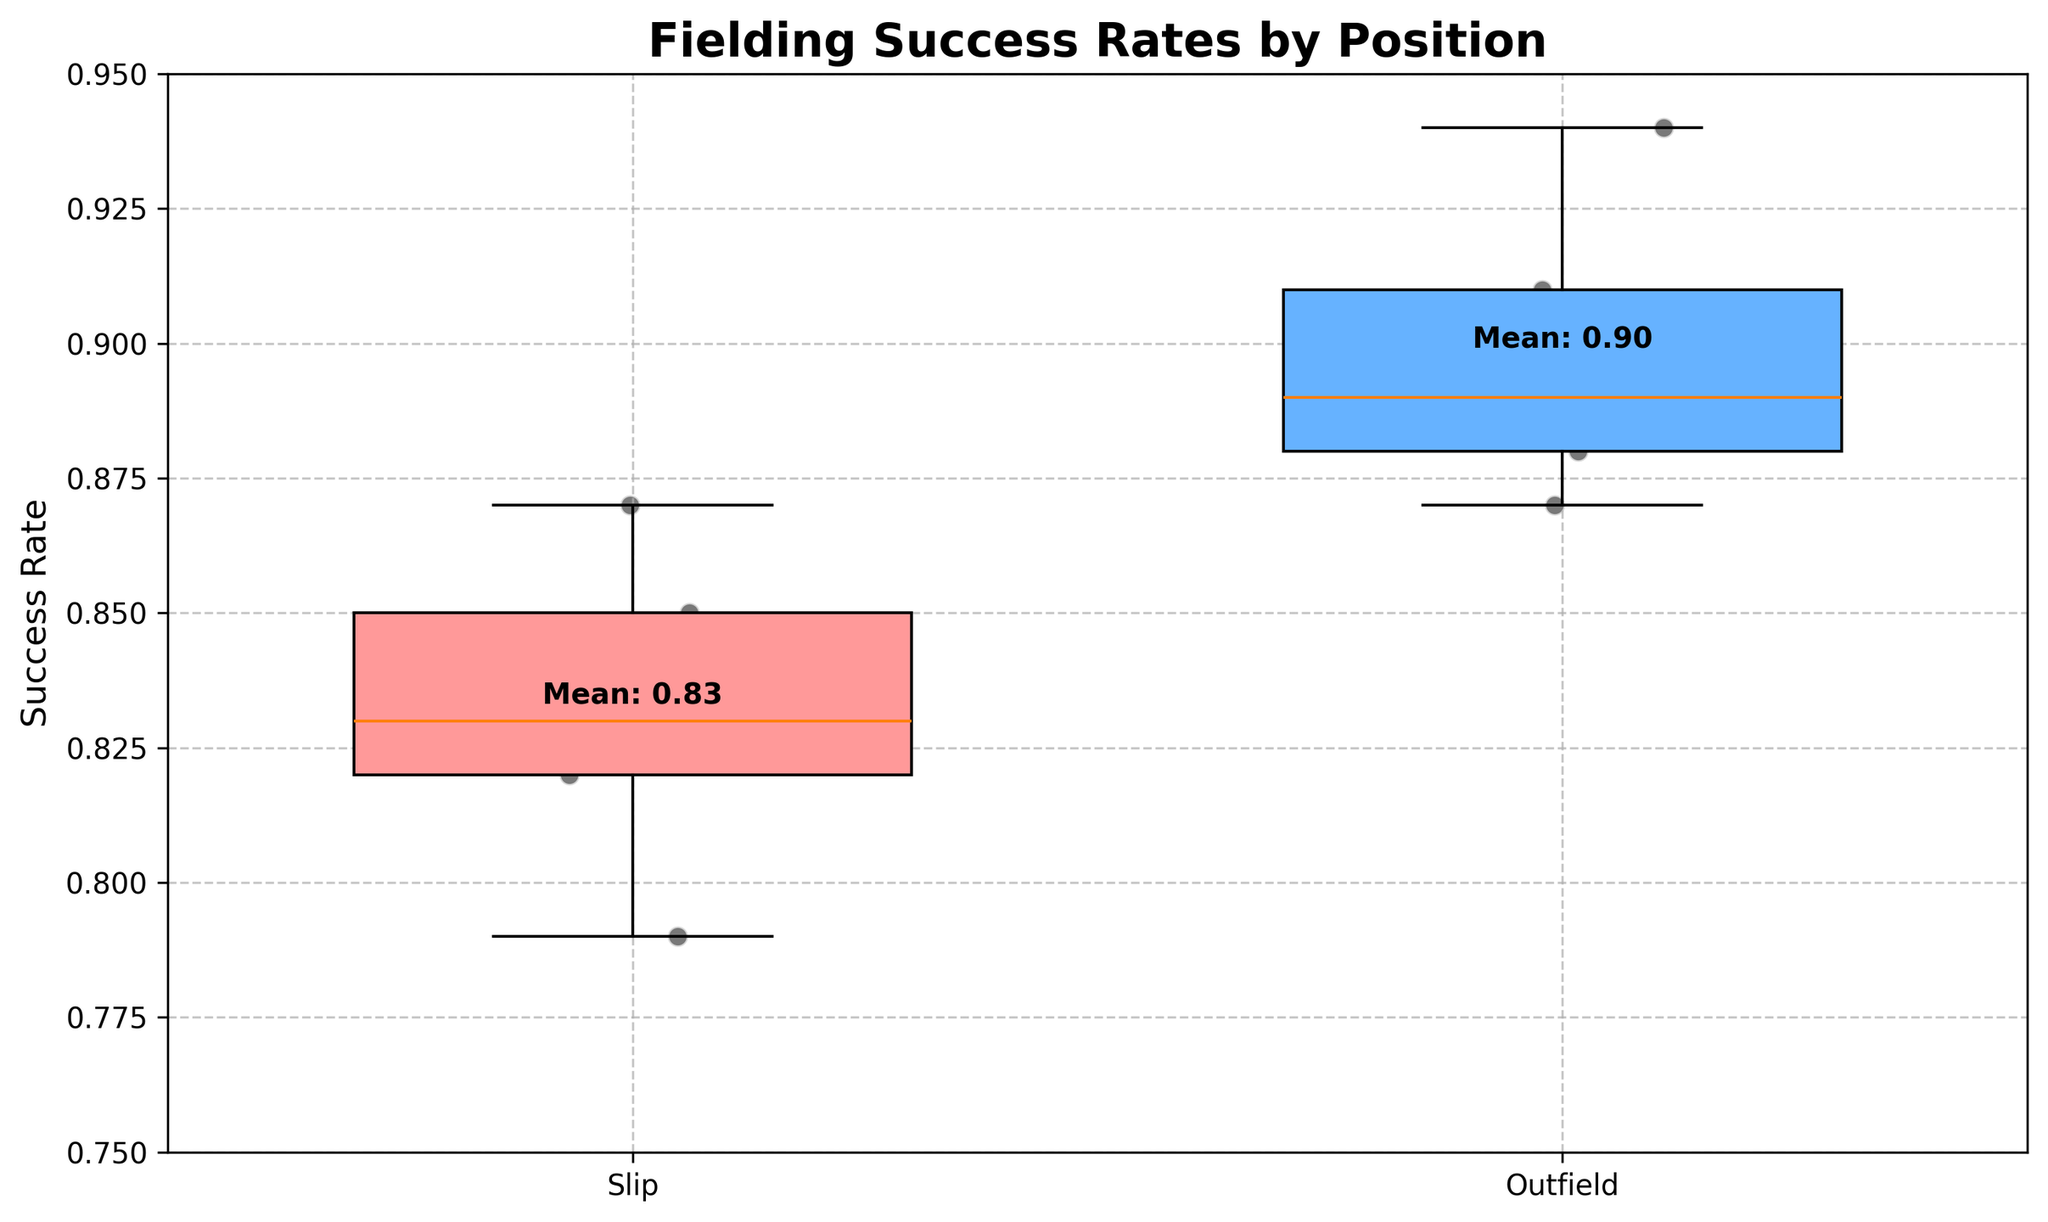How many data points represent the success rate for slip fielders? Count the number of data points in the "slip" category on the box plot
Answer: 5 What is the title of the plot? Read the text at the top of the plot
Answer: Fielding Success Rates by Position Which fielding position has the higher mean success rate? Look at the mean value labels on the plot. Compare the means for slip and outfield
Answer: Outfield What is the range of success rates for outfield players? Identify the minimum and maximum values from the box plot for the outfield group
Answer: 0.87 to 0.94 How does the interquartile range (IQR) for slip fielders compare to the IQR for outfielders? Compare the length of the boxes (spanning the 1st and 3rd quartiles) in both groups
Answer: Larger for outfield What is the lowest success rate among slip fielders? Find the bottom whisker or the lowest individual data point in the slip group
Answer: 0.79 How does the median success rate for slip fielders compare to the median success rate for outfielders? Identify and compare the median lines within each box
Answer: Slip is lower Which fielding position shows greater variability in success rates? Compare the overall spread of data points and the length of the whiskers in both groups
Answer: Outfield Is there any overlap in the success range between the slip and outfield positions? Identify overlapping regions between the two box plots
Answer: Yes, from 0.87 to 0.88 